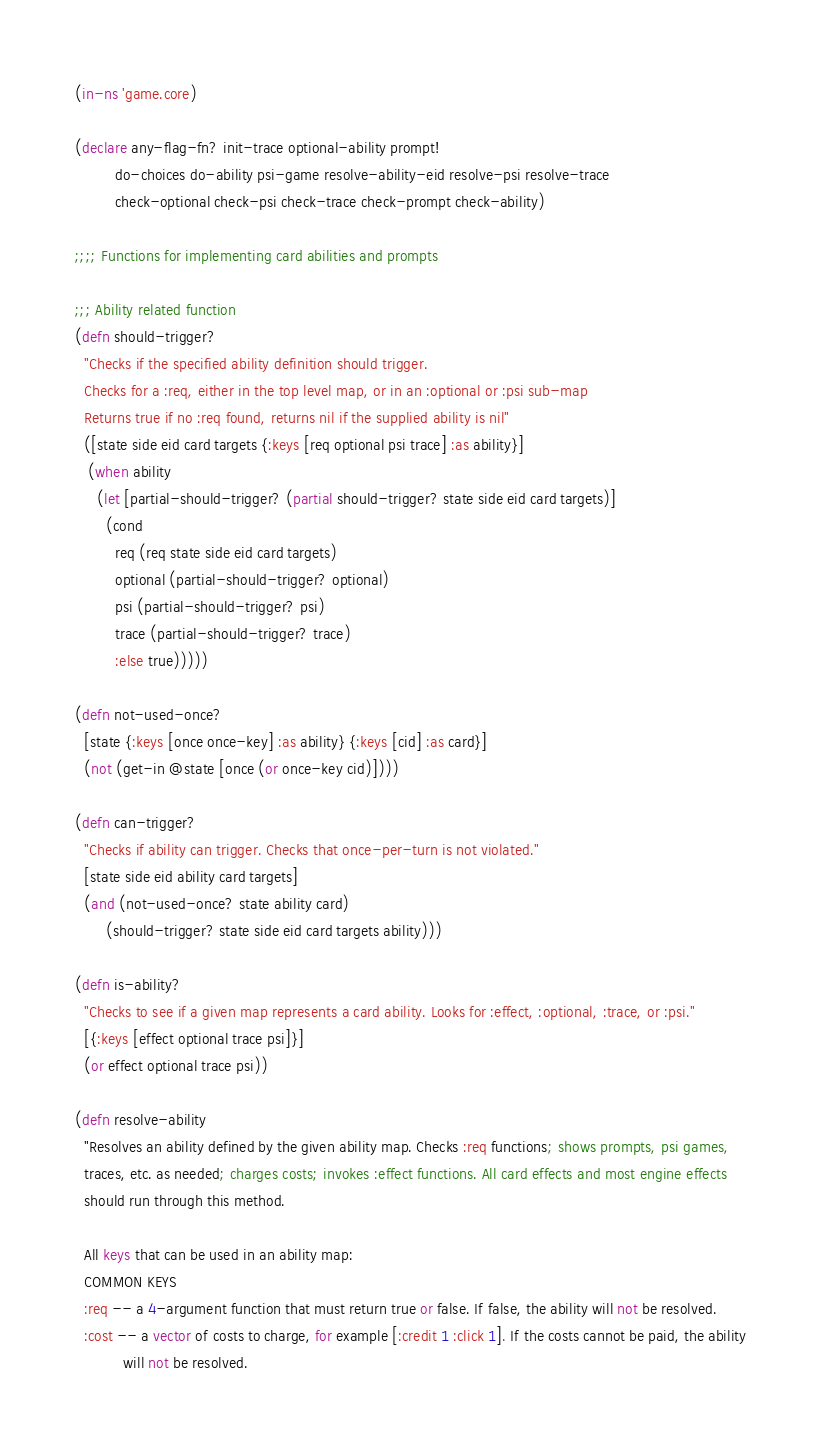Convert code to text. <code><loc_0><loc_0><loc_500><loc_500><_Clojure_>(in-ns 'game.core)

(declare any-flag-fn? init-trace optional-ability prompt!
         do-choices do-ability psi-game resolve-ability-eid resolve-psi resolve-trace
         check-optional check-psi check-trace check-prompt check-ability)

;;;; Functions for implementing card abilities and prompts

;;; Ability related function
(defn should-trigger?
  "Checks if the specified ability definition should trigger.
  Checks for a :req, either in the top level map, or in an :optional or :psi sub-map
  Returns true if no :req found, returns nil if the supplied ability is nil"
  ([state side eid card targets {:keys [req optional psi trace] :as ability}]
   (when ability
     (let [partial-should-trigger? (partial should-trigger? state side eid card targets)]
       (cond
         req (req state side eid card targets)
         optional (partial-should-trigger? optional)
         psi (partial-should-trigger? psi)
         trace (partial-should-trigger? trace)
         :else true)))))

(defn not-used-once?
  [state {:keys [once once-key] :as ability} {:keys [cid] :as card}]
  (not (get-in @state [once (or once-key cid)])))

(defn can-trigger?
  "Checks if ability can trigger. Checks that once-per-turn is not violated."
  [state side eid ability card targets]
  (and (not-used-once? state ability card)
       (should-trigger? state side eid card targets ability)))

(defn is-ability?
  "Checks to see if a given map represents a card ability. Looks for :effect, :optional, :trace, or :psi."
  [{:keys [effect optional trace psi]}]
  (or effect optional trace psi))

(defn resolve-ability
  "Resolves an ability defined by the given ability map. Checks :req functions; shows prompts, psi games,
  traces, etc. as needed; charges costs; invokes :effect functions. All card effects and most engine effects
  should run through this method.

  All keys that can be used in an ability map:
  COMMON KEYS
  :req -- a 4-argument function that must return true or false. If false, the ability will not be resolved.
  :cost -- a vector of costs to charge, for example [:credit 1 :click 1]. If the costs cannot be paid, the ability
           will not be resolved.</code> 